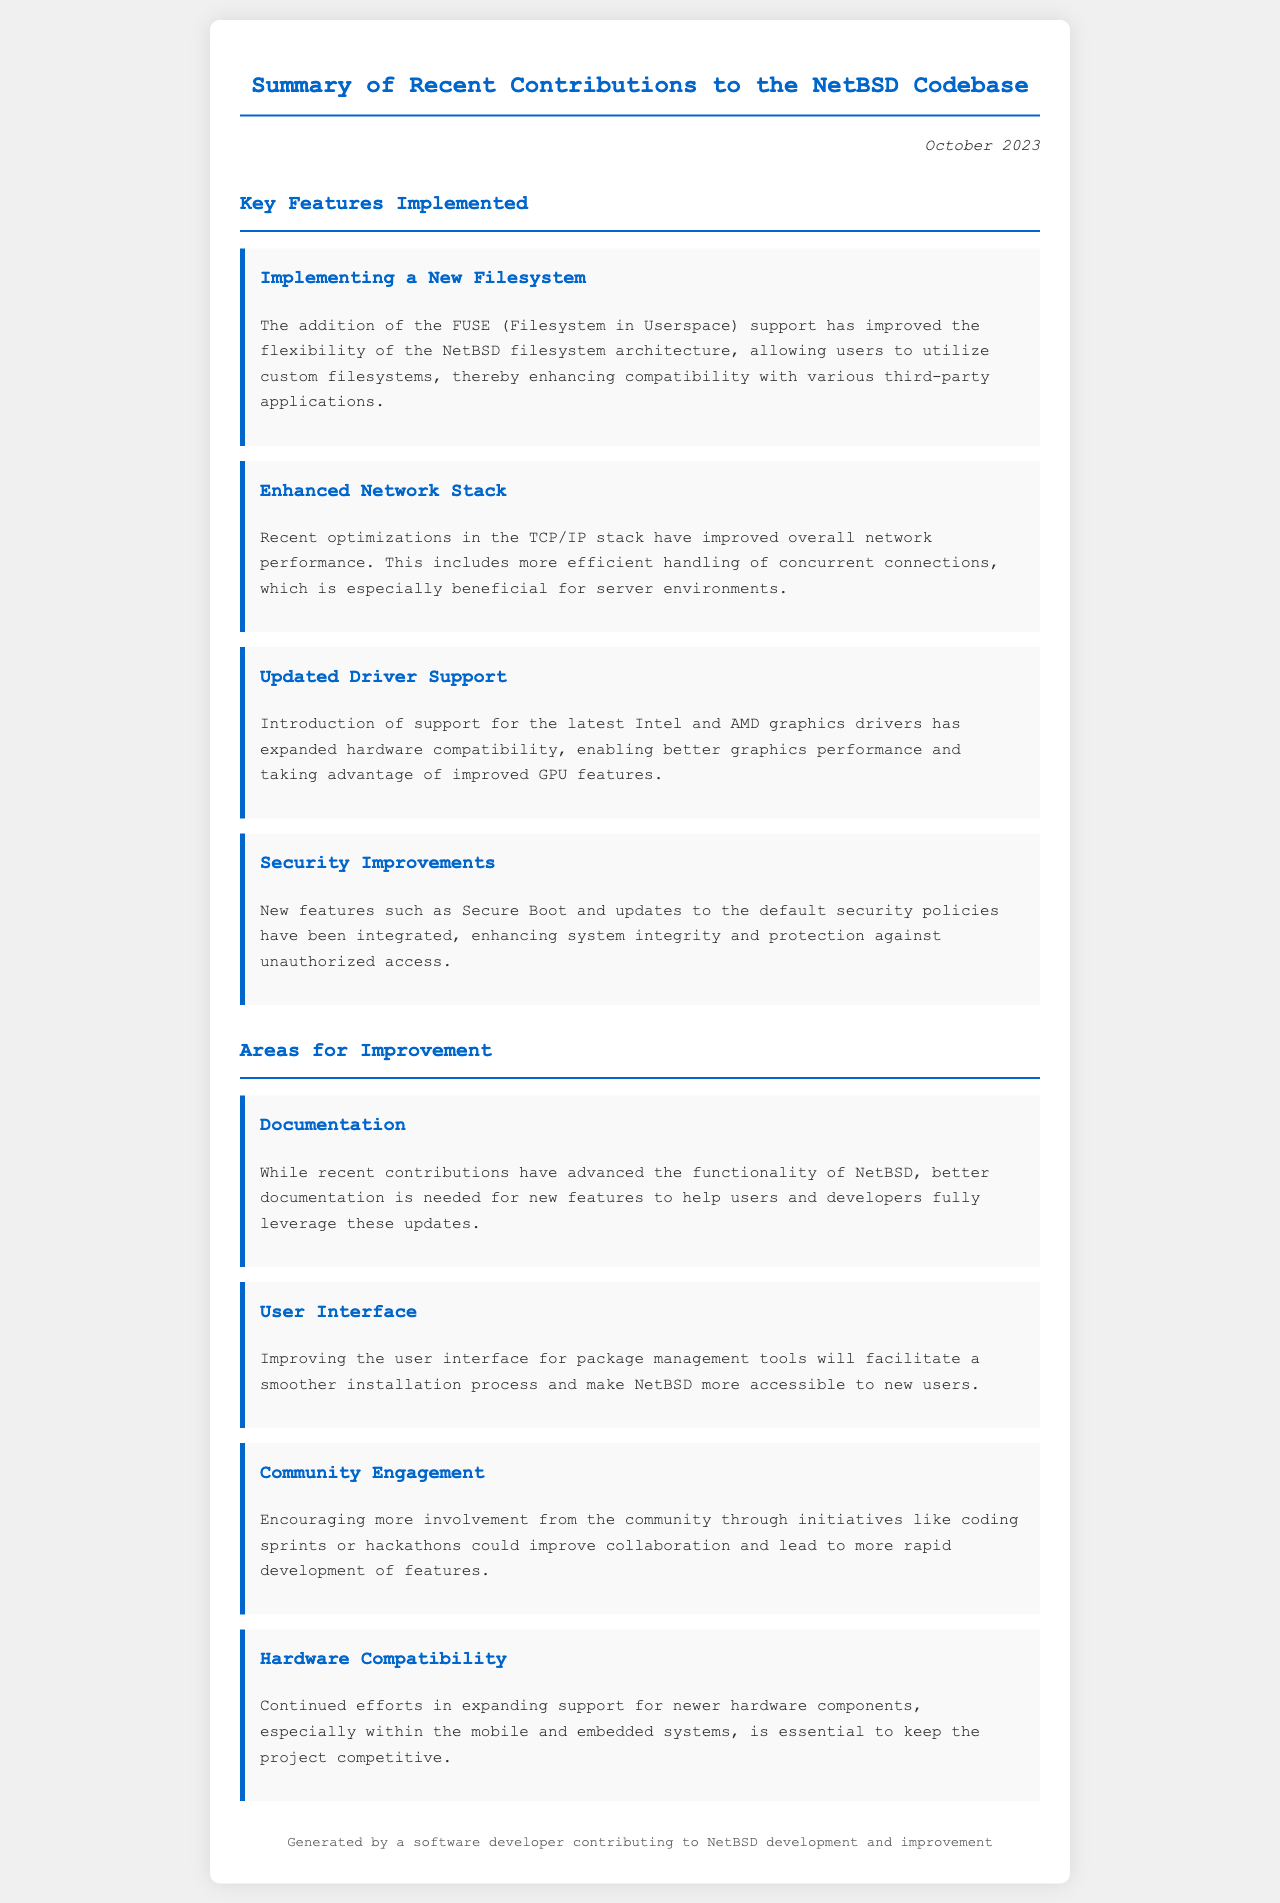what is the date of the document? The document states the date at the top as "October 2023."
Answer: October 2023 what new filesystem feature was implemented? The document mentions "FUSE (Filesystem in Userspace) support" as the new filesystem feature.
Answer: FUSE (Filesystem in Userspace) what improvement was made to the network stack? The document highlights "optimizations in the TCP/IP stack" for improving network performance.
Answer: optimizations in the TCP/IP stack how many key features are implemented? The document lists four key features under the "Key Features Implemented" section.
Answer: four what area needs better documentation? The document identifies "Documentation" as an area needing improvement.
Answer: Documentation which hardware support was expanded? The document states that support for "Intel and AMD graphics drivers" was expanded.
Answer: Intel and AMD graphics drivers what is one reason for improving community engagement? The document suggests that "coding sprints or hackathons" could improve collaboration.
Answer: coding sprints or hackathons what aspect of NetBSD is essential for its competitiveness? The document mentions "expanding support for newer hardware components" as essential.
Answer: expanding support for newer hardware components how does the document suggest improving package management tools? The document states that improving "user interface" for package management tools is recommended.
Answer: user interface 